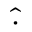Convert formula to latex. <formula><loc_0><loc_0><loc_500><loc_500>\widehat { \cdot }</formula> 